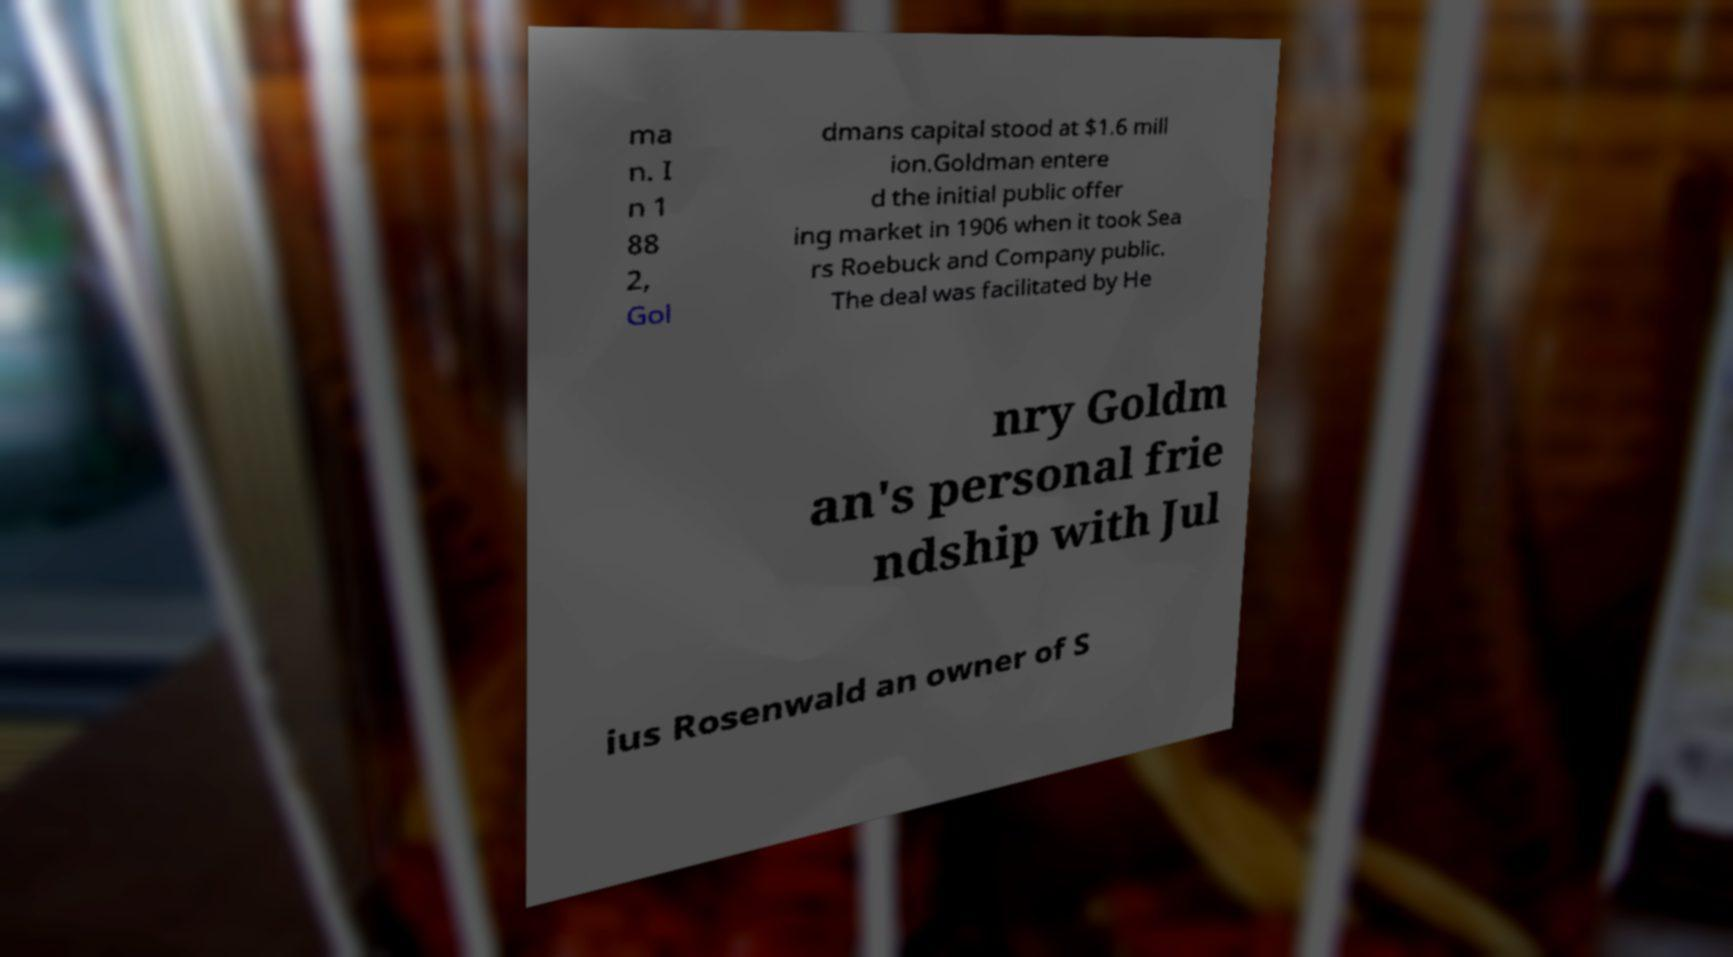Could you assist in decoding the text presented in this image and type it out clearly? ma n. I n 1 88 2, Gol dmans capital stood at $1.6 mill ion.Goldman entere d the initial public offer ing market in 1906 when it took Sea rs Roebuck and Company public. The deal was facilitated by He nry Goldm an's personal frie ndship with Jul ius Rosenwald an owner of S 